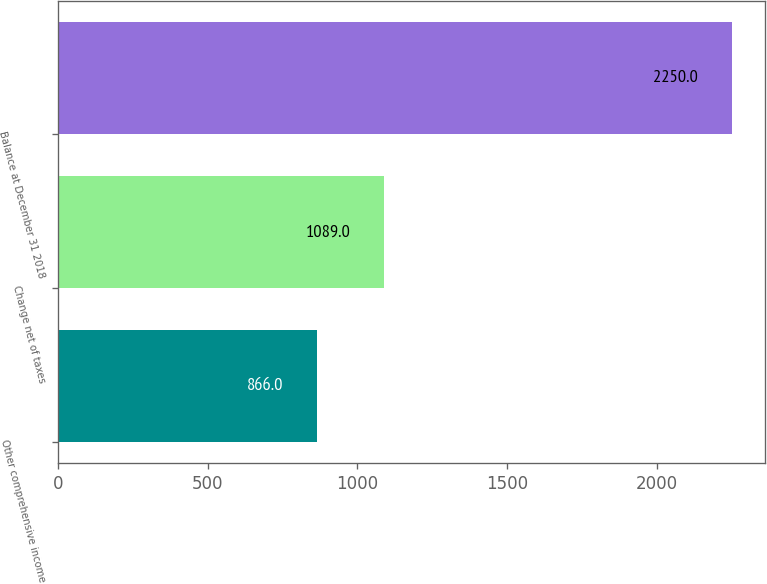Convert chart to OTSL. <chart><loc_0><loc_0><loc_500><loc_500><bar_chart><fcel>Other comprehensive income<fcel>Change net of taxes<fcel>Balance at December 31 2018<nl><fcel>866<fcel>1089<fcel>2250<nl></chart> 